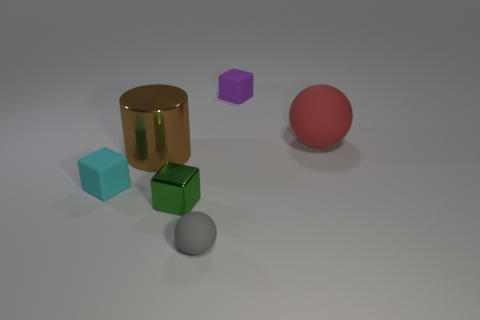Add 1 small cyan things. How many objects exist? 7 Subtract all spheres. How many objects are left? 4 Subtract 0 yellow cubes. How many objects are left? 6 Subtract all red objects. Subtract all tiny brown matte balls. How many objects are left? 5 Add 3 large spheres. How many large spheres are left? 4 Add 2 red cubes. How many red cubes exist? 2 